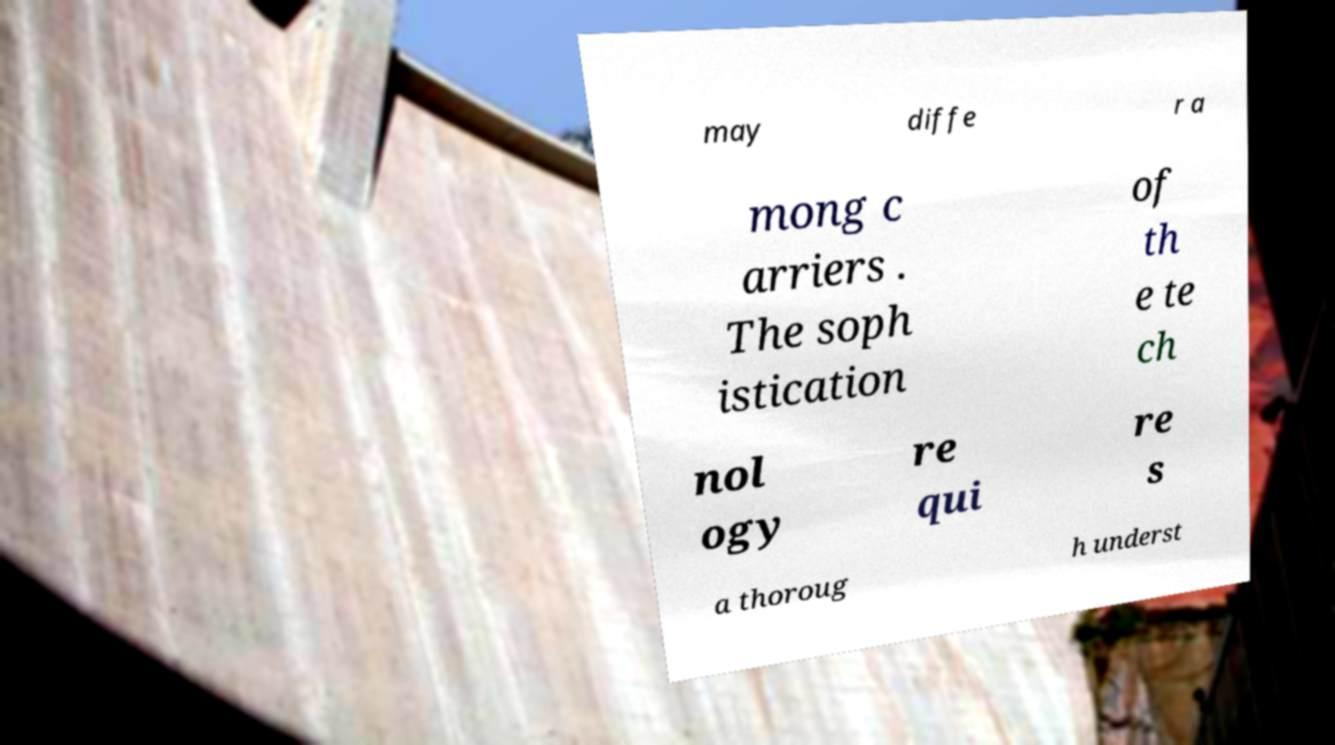Could you assist in decoding the text presented in this image and type it out clearly? may diffe r a mong c arriers . The soph istication of th e te ch nol ogy re qui re s a thoroug h underst 